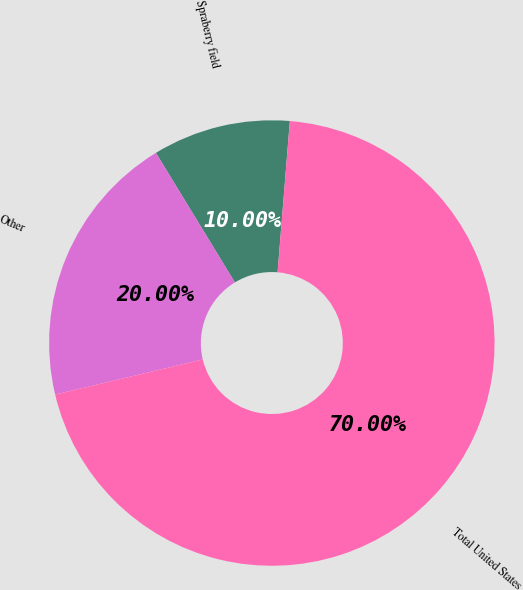<chart> <loc_0><loc_0><loc_500><loc_500><pie_chart><fcel>Spraberry field<fcel>Other<fcel>Total United States<nl><fcel>10.0%<fcel>20.0%<fcel>70.0%<nl></chart> 